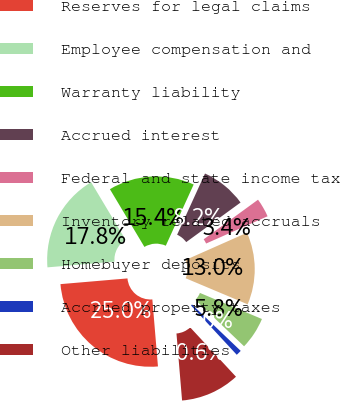Convert chart to OTSL. <chart><loc_0><loc_0><loc_500><loc_500><pie_chart><fcel>Reserves for legal claims<fcel>Employee compensation and<fcel>Warranty liability<fcel>Accrued interest<fcel>Federal and state income tax<fcel>Inventory related accruals<fcel>Homebuyer deposits<fcel>Accrued property taxes<fcel>Other liabilities<nl><fcel>24.98%<fcel>17.78%<fcel>15.38%<fcel>8.18%<fcel>3.38%<fcel>12.98%<fcel>5.78%<fcel>0.98%<fcel>10.58%<nl></chart> 